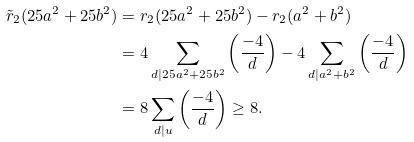Convert formula to latex. <formula><loc_0><loc_0><loc_500><loc_500>\tilde { r } _ { 2 } ( 2 5 a ^ { 2 } + 2 5 b ^ { 2 } ) & = r _ { 2 } ( 2 5 a ^ { 2 } + 2 5 b ^ { 2 } ) - r _ { 2 } ( a ^ { 2 } + b ^ { 2 } ) \\ & = 4 \sum _ { d | 2 5 a ^ { 2 } + 2 5 b ^ { 2 } } \left ( \frac { - 4 } { d } \right ) - 4 \sum _ { d | a ^ { 2 } + b ^ { 2 } } \left ( \frac { - 4 } { d } \right ) \\ & = 8 \sum _ { d | u } \left ( \frac { - 4 } { d } \right ) \geq 8 .</formula> 